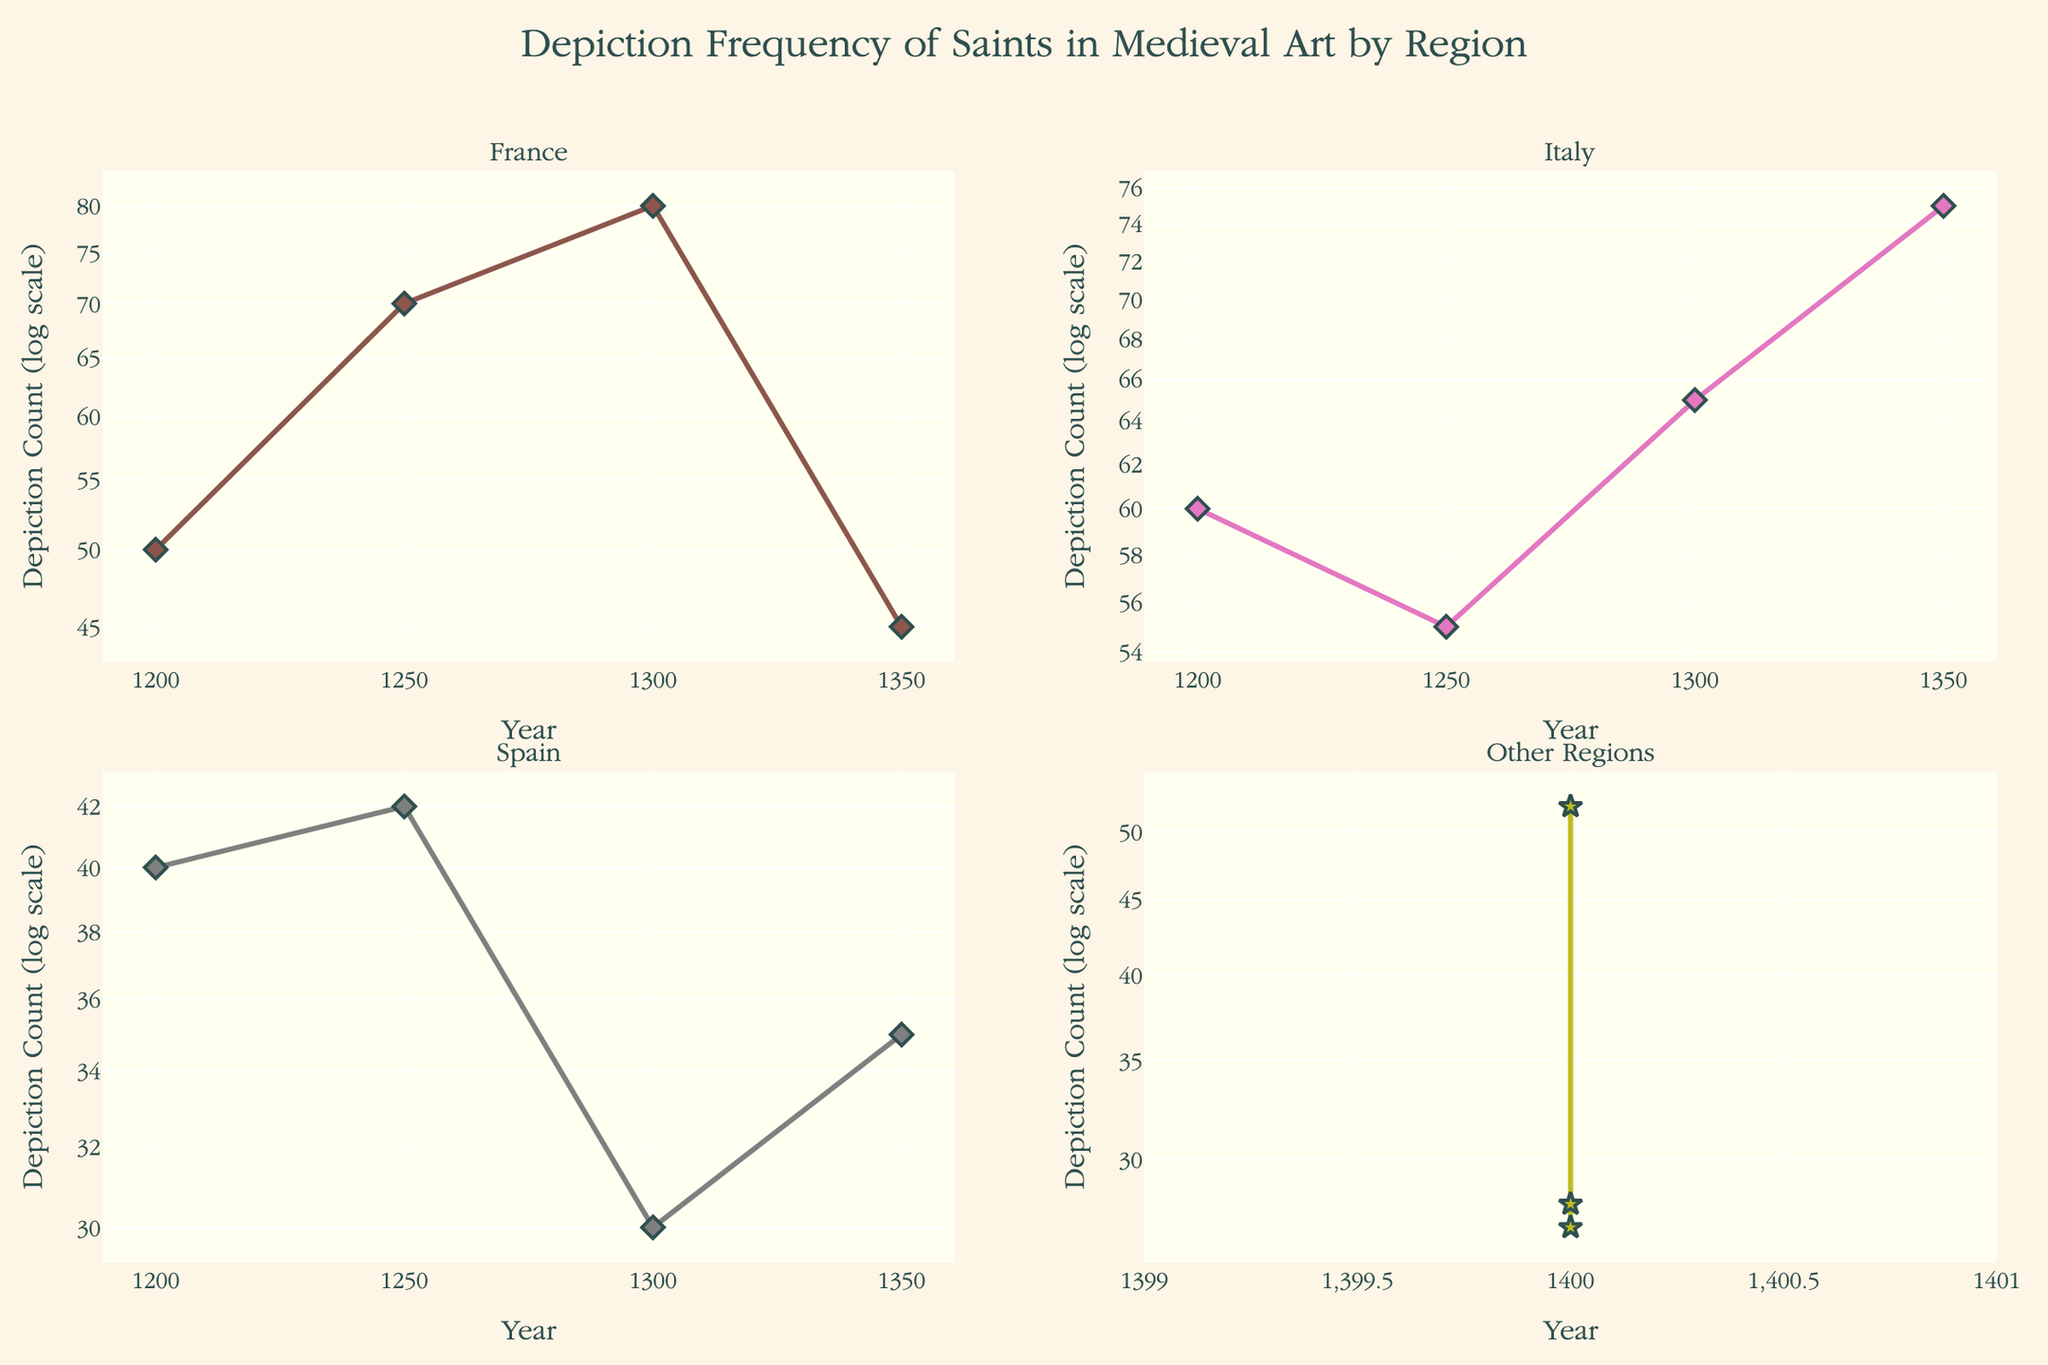What is the title of the figure? The title is located at the top center of the figure, and it reads "Depiction Frequency of Saints in Medieval Art by Region".
Answer: Depiction Frequency of Saints in Medieval Art by Region Which subplot has the highest depiction count in the year 1350? The highest depiction count in 1350 can be found by examining the subplots for France, Italy, Spain, and Other Regions. France has 45, Italy has 75, and Spain has 35. Italy has the highest depiction count.
Answer: Italy How does the depiction count of saints in Spain change from 1200 to 1350? To answer this, look at the Spain subplot. In 1200, the count is 40, in 1250 it is 42, and in 1350 it is 30. The depiction count decreases overall from 40 to 30 over the period.
Answer: Decreases Which region shown has the most consistent depiction count over the years? By examining each subplot, consistency can be judged. France varies from 50 to 80 to 45, Italy from 60 to 75, Spain from 40 to 30, and Other Regions vary from 28 to 27 to 52. Italy's lower variability suggests the most consistency.
Answer: Italy In which year did France have the highest depiction count? In the France subplot, the depiction counts for each year are given: 1200 (50), 1250 (70), 1300 (80), and 1350 (45). The year 1300 had the highest depiction count at 80.
Answer: 1300 Compare the depiction counts of St. Denis and St. Genevieve. Which saint had a higher count and by how much? St. Denis is shown in 1200 with a count of 50, and St. Genevieve in 1350 with 45. St. Denis had a higher count by 5.
Answer: St. Denis by 5 What is the overall trend in the depiction count of saints in the Other Regions subplot from 1400 to 1350? In the Other Regions subplot, the depiction counts are 28 for St. Boniface, 52 for St. Thomas Becket, and 27 for St. Willibrord. Therefore, the depiction count decreased overall from 52 to 27.
Answer: Decreases Which saint depicted in Italy had the highest depiction count, and in which year? By looking at the Italy subplot, St. Anthony of Padua in 1350 had the highest count of 75.
Answer: St. Anthony of Padua in 1350 How many saints are depicted in the figure for the year 1300 across all regions? Count the number of data points shown in 1300 across all subplots. France has 1, Italy has 1, Spain has 1, and Other Regions have none for 1300. There are 3 saints depicted in 1300.
Answer: 3 